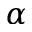<formula> <loc_0><loc_0><loc_500><loc_500>\alpha</formula> 